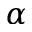<formula> <loc_0><loc_0><loc_500><loc_500>\alpha</formula> 